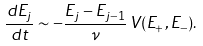<formula> <loc_0><loc_0><loc_500><loc_500>\frac { d E _ { j } } { d t } \sim - \frac { E _ { j } - E _ { j - 1 } } { \nu } \, V ( E _ { + } , E _ { - } ) .</formula> 